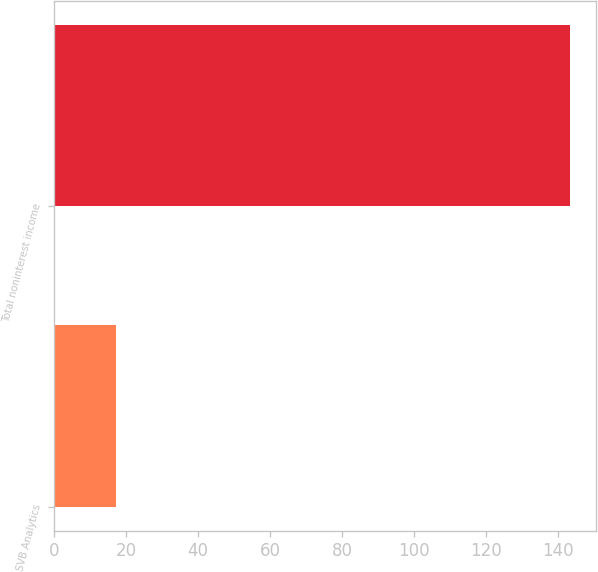<chart> <loc_0><loc_0><loc_500><loc_500><bar_chart><fcel>SVB Analytics<fcel>Total noninterest income<nl><fcel>17.1<fcel>143.5<nl></chart> 